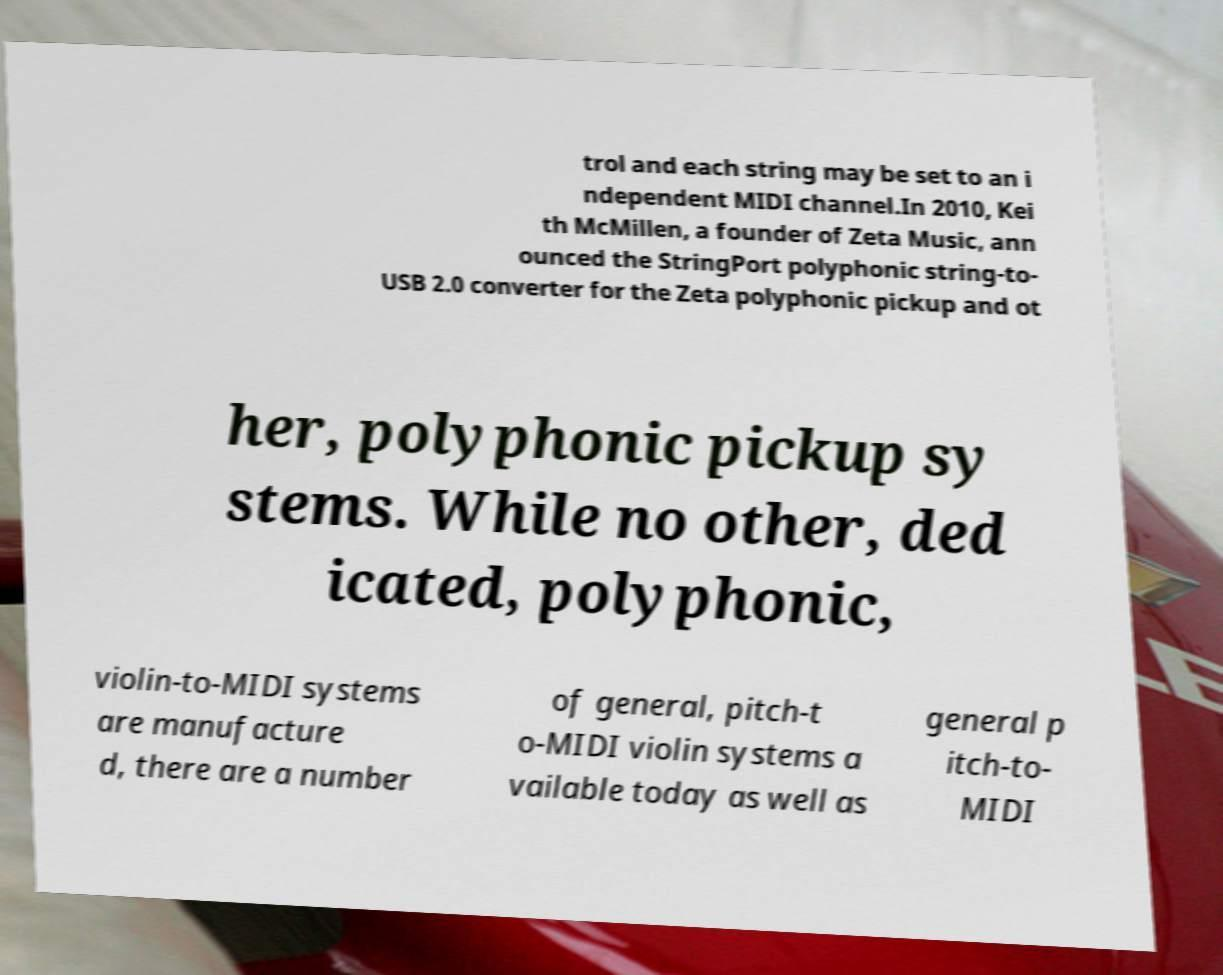For documentation purposes, I need the text within this image transcribed. Could you provide that? trol and each string may be set to an i ndependent MIDI channel.In 2010, Kei th McMillen, a founder of Zeta Music, ann ounced the StringPort polyphonic string-to- USB 2.0 converter for the Zeta polyphonic pickup and ot her, polyphonic pickup sy stems. While no other, ded icated, polyphonic, violin-to-MIDI systems are manufacture d, there are a number of general, pitch-t o-MIDI violin systems a vailable today as well as general p itch-to- MIDI 